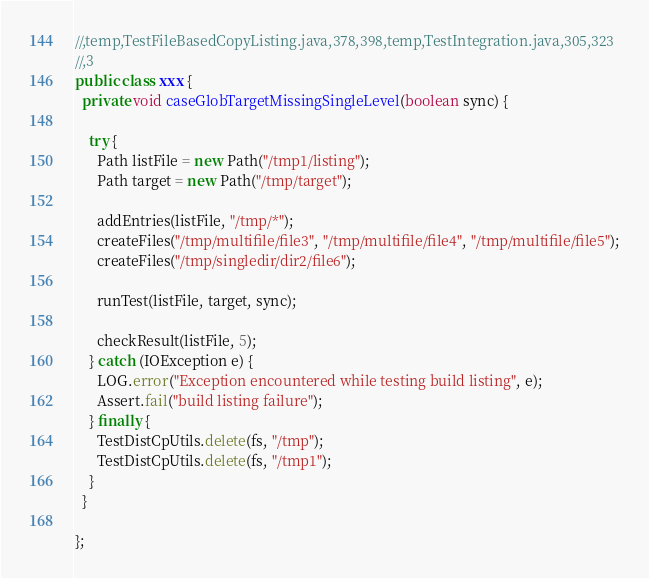Convert code to text. <code><loc_0><loc_0><loc_500><loc_500><_Java_>//,temp,TestFileBasedCopyListing.java,378,398,temp,TestIntegration.java,305,323
//,3
public class xxx {
  private void caseGlobTargetMissingSingleLevel(boolean sync) {

    try {
      Path listFile = new Path("/tmp1/listing");
      Path target = new Path("/tmp/target");

      addEntries(listFile, "/tmp/*");
      createFiles("/tmp/multifile/file3", "/tmp/multifile/file4", "/tmp/multifile/file5");
      createFiles("/tmp/singledir/dir2/file6");

      runTest(listFile, target, sync);

      checkResult(listFile, 5);
    } catch (IOException e) {
      LOG.error("Exception encountered while testing build listing", e);
      Assert.fail("build listing failure");
    } finally {
      TestDistCpUtils.delete(fs, "/tmp");
      TestDistCpUtils.delete(fs, "/tmp1");
    }
  }

};</code> 